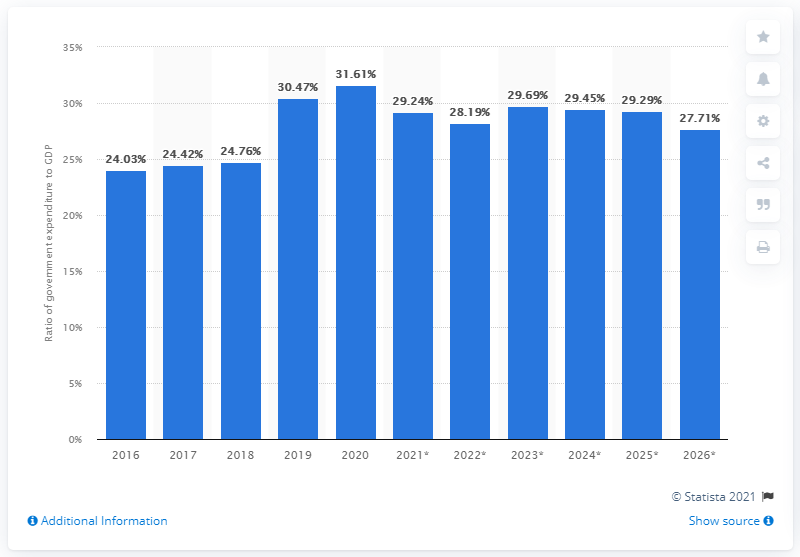Specify some key components in this picture. In 2020, government expenditure in Mauritius constituted 31.61% of the country's gross domestic product. 